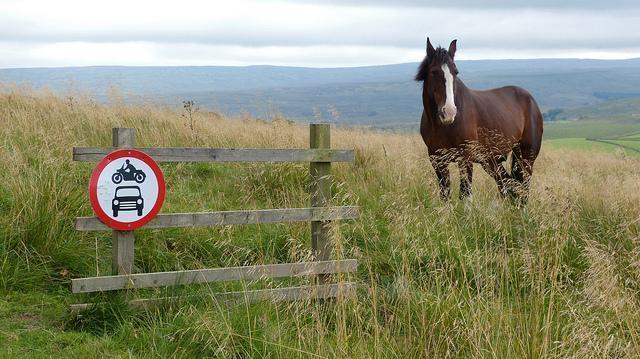How many horses are in the picture?
Give a very brief answer. 1. How many wheels does the skateboard have?
Give a very brief answer. 0. 